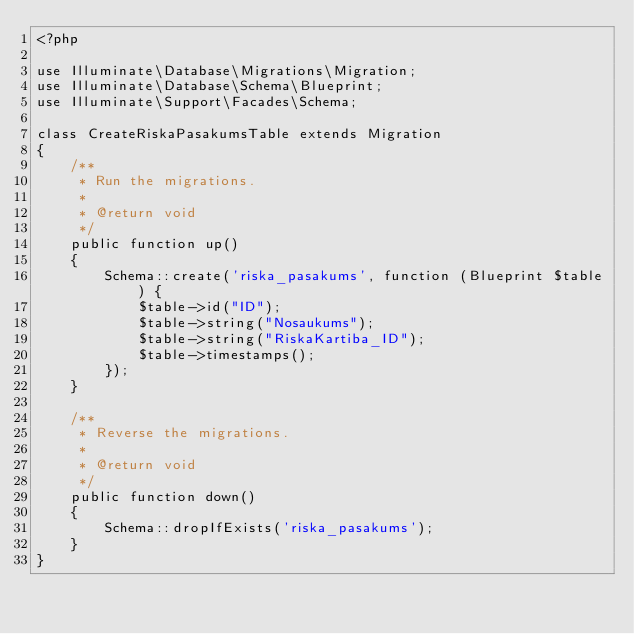<code> <loc_0><loc_0><loc_500><loc_500><_PHP_><?php

use Illuminate\Database\Migrations\Migration;
use Illuminate\Database\Schema\Blueprint;
use Illuminate\Support\Facades\Schema;

class CreateRiskaPasakumsTable extends Migration
{
    /**
     * Run the migrations.
     *
     * @return void
     */
    public function up()
    {
        Schema::create('riska_pasakums', function (Blueprint $table) {
            $table->id("ID");
            $table->string("Nosaukums");
            $table->string("RiskaKartiba_ID");
            $table->timestamps();
        });
    }

    /**
     * Reverse the migrations.
     *
     * @return void
     */
    public function down()
    {
        Schema::dropIfExists('riska_pasakums');
    }
}
</code> 